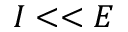Convert formula to latex. <formula><loc_0><loc_0><loc_500><loc_500>I < < E</formula> 